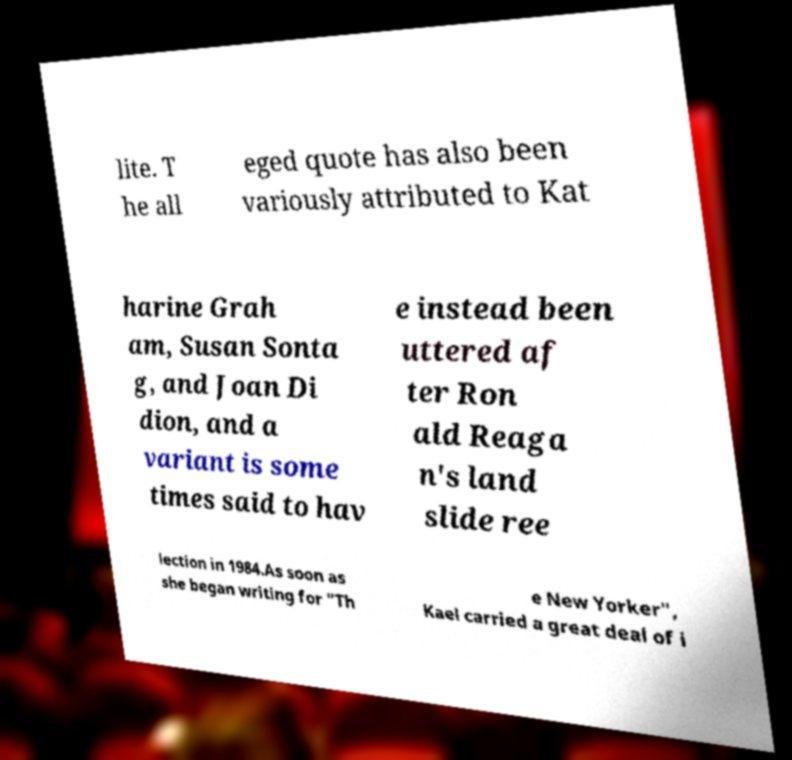Please read and relay the text visible in this image. What does it say? lite. T he all eged quote has also been variously attributed to Kat harine Grah am, Susan Sonta g, and Joan Di dion, and a variant is some times said to hav e instead been uttered af ter Ron ald Reaga n's land slide ree lection in 1984.As soon as she began writing for "Th e New Yorker", Kael carried a great deal of i 